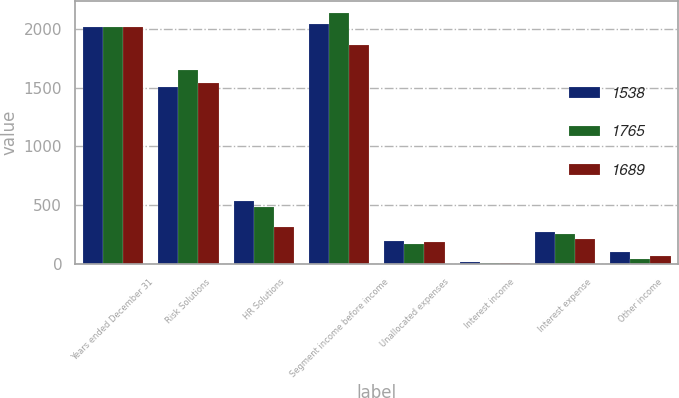Convert chart. <chart><loc_0><loc_0><loc_500><loc_500><stacked_bar_chart><ecel><fcel>Years ended December 31<fcel>Risk Solutions<fcel>HR Solutions<fcel>Segment income before income<fcel>Unallocated expenses<fcel>Interest income<fcel>Interest expense<fcel>Other income<nl><fcel>1538<fcel>2015<fcel>1506<fcel>536<fcel>2042<fcel>194<fcel>14<fcel>273<fcel>100<nl><fcel>1765<fcel>2014<fcel>1648<fcel>485<fcel>2133<fcel>167<fcel>10<fcel>255<fcel>44<nl><fcel>1689<fcel>2013<fcel>1540<fcel>318<fcel>1858<fcel>187<fcel>9<fcel>210<fcel>68<nl></chart> 